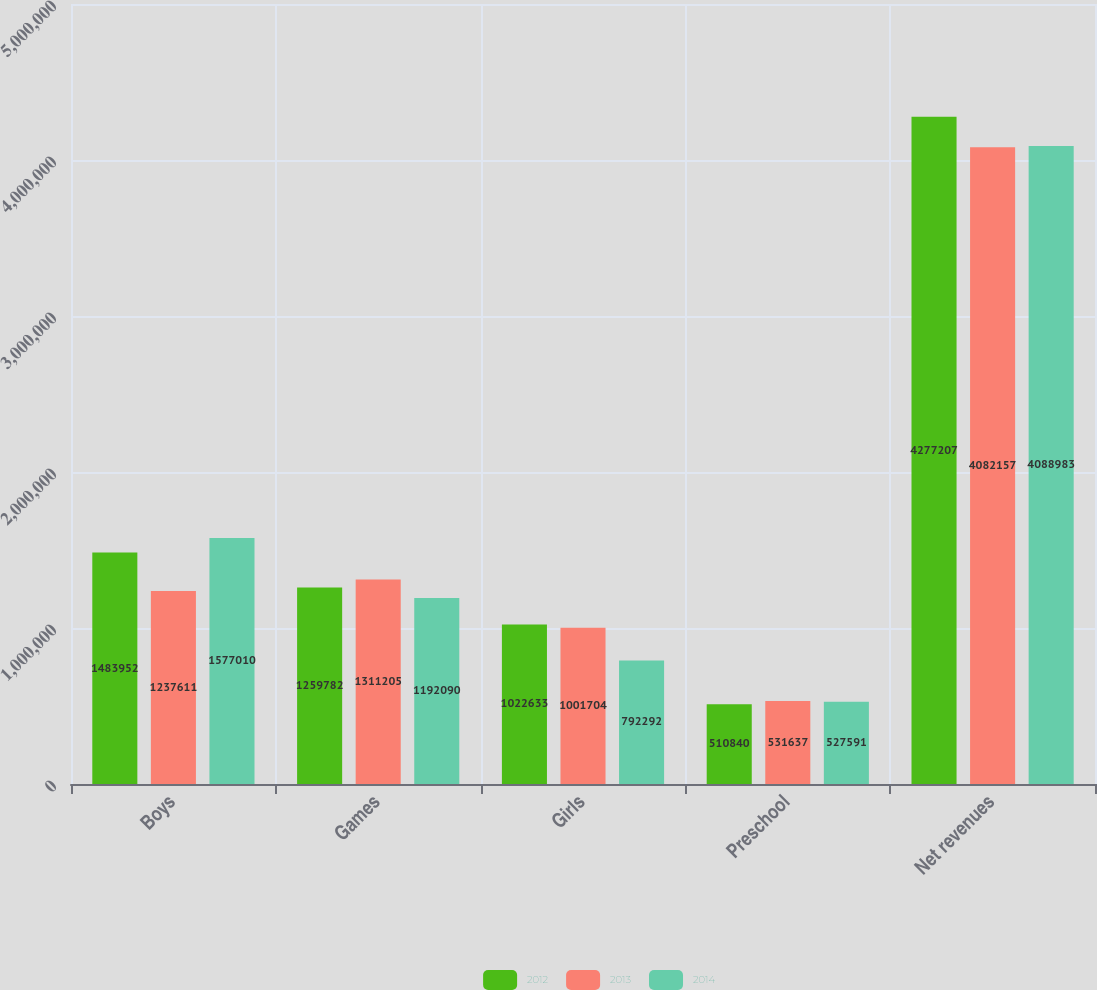Convert chart. <chart><loc_0><loc_0><loc_500><loc_500><stacked_bar_chart><ecel><fcel>Boys<fcel>Games<fcel>Girls<fcel>Preschool<fcel>Net revenues<nl><fcel>2012<fcel>1.48395e+06<fcel>1.25978e+06<fcel>1.02263e+06<fcel>510840<fcel>4.27721e+06<nl><fcel>2013<fcel>1.23761e+06<fcel>1.3112e+06<fcel>1.0017e+06<fcel>531637<fcel>4.08216e+06<nl><fcel>2014<fcel>1.57701e+06<fcel>1.19209e+06<fcel>792292<fcel>527591<fcel>4.08898e+06<nl></chart> 